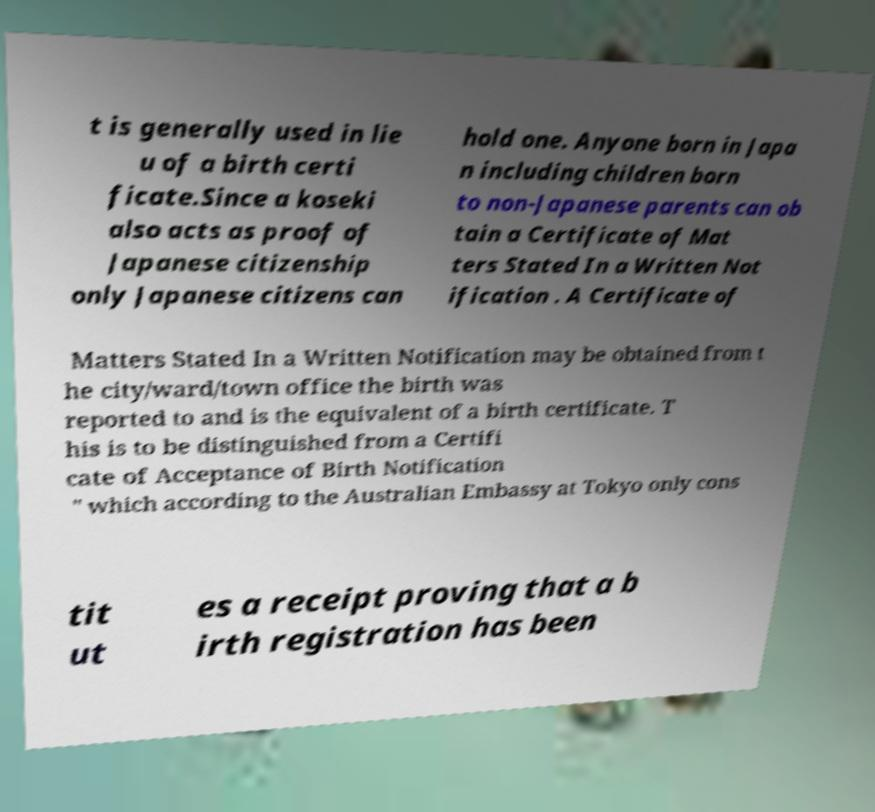Could you assist in decoding the text presented in this image and type it out clearly? t is generally used in lie u of a birth certi ficate.Since a koseki also acts as proof of Japanese citizenship only Japanese citizens can hold one. Anyone born in Japa n including children born to non-Japanese parents can ob tain a Certificate of Mat ters Stated In a Written Not ification . A Certificate of Matters Stated In a Written Notification may be obtained from t he city/ward/town office the birth was reported to and is the equivalent of a birth certificate. T his is to be distinguished from a Certifi cate of Acceptance of Birth Notification " which according to the Australian Embassy at Tokyo only cons tit ut es a receipt proving that a b irth registration has been 